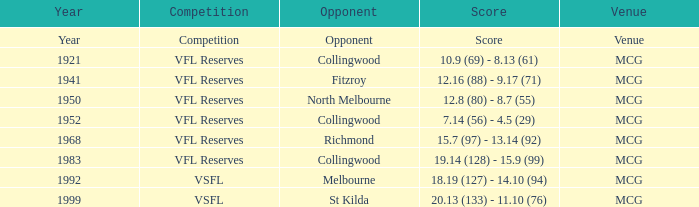In what competition was the score reported as 12.8 (80) - 8.7 (55)? VFL Reserves. 